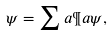Convert formula to latex. <formula><loc_0><loc_0><loc_500><loc_500>\psi = \sum a \P a \psi ,</formula> 